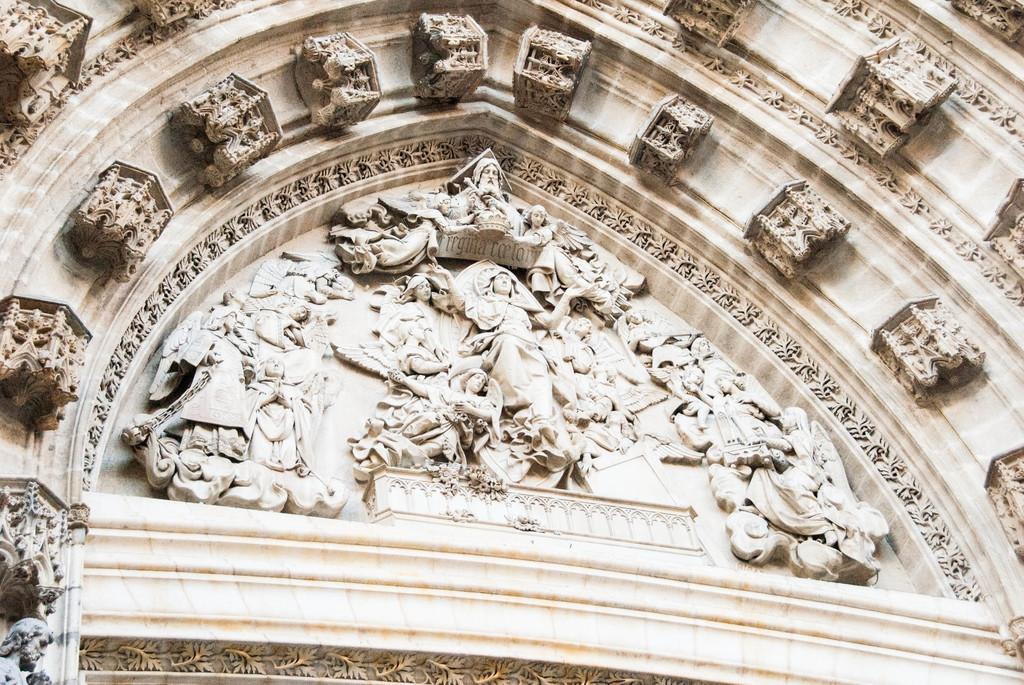What is present on the wall in the image? There are sculptures and text on the wall in the image. Can you describe the sculptures on the wall? Unfortunately, the specific details of the sculptures cannot be determined from the provided facts. What type of information is conveyed by the text on the wall? The content of the text on the wall cannot be determined from the provided facts. What type of eggnog is being served at the game in the image? There is no game or eggnog present in the image. Is the queen in the image enjoying the eggnog at the game? There is no queen, game, or eggnog present in the image. 